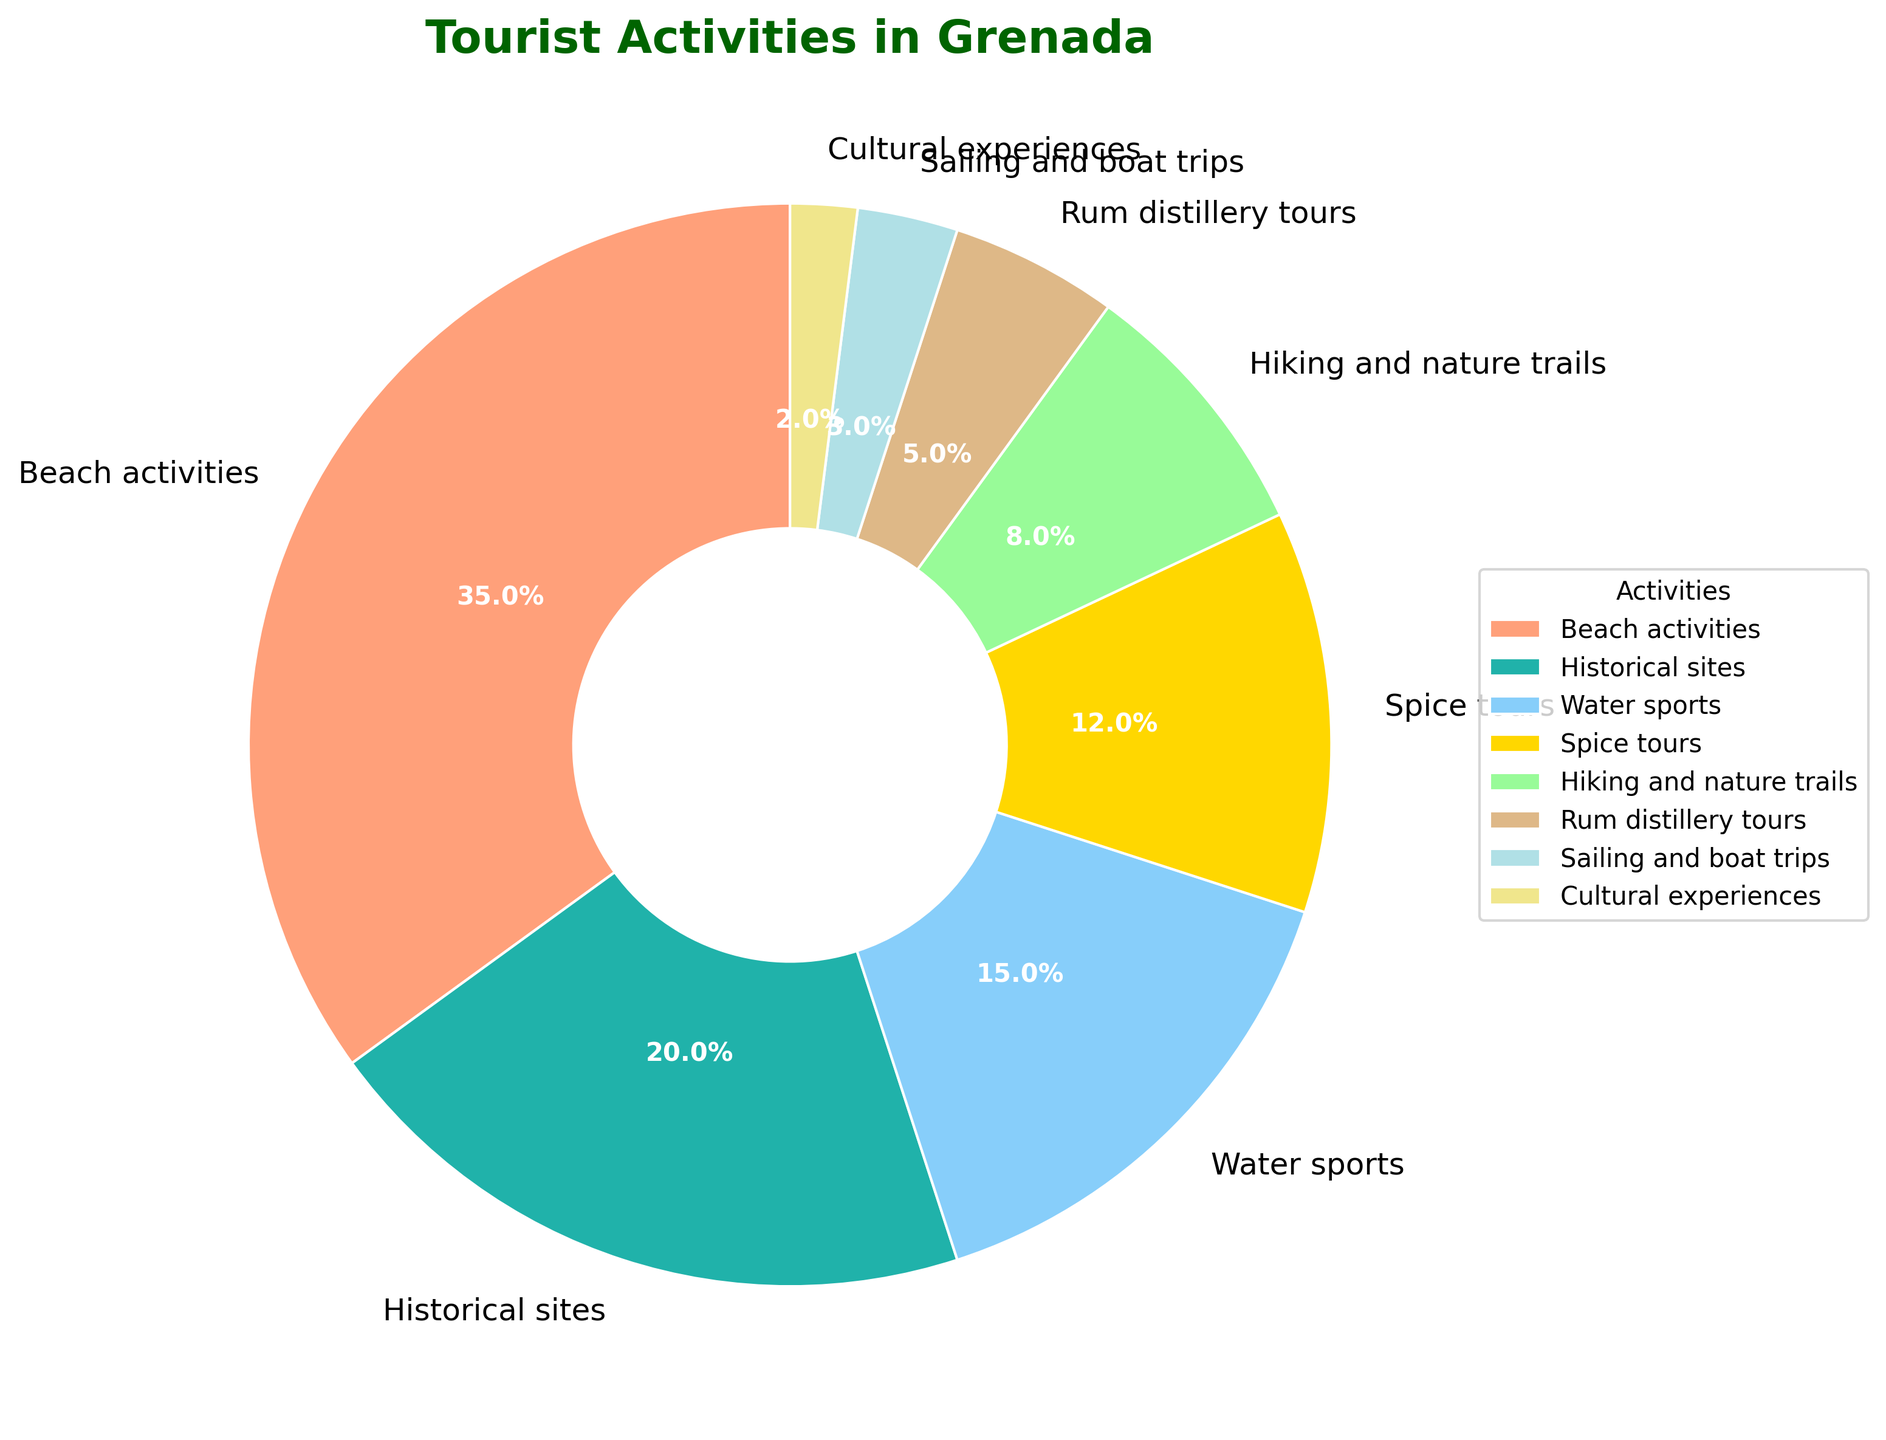What proportion of tourist activities is dedicated to beach activities? The pie chart shows the percentage of each tourist activity. According to the chart, the proportion dedicated to beach activities is labeled directly in the section for Beach activities.
Answer: 35% Which activity has the smallest percentage share? By examining the pie chart, the smallest segment can be identified by its size and the percentage label. The smallest segment is labeled as Cultural experiences with a 2% share.
Answer: Cultural experiences What is the combined percentage for water sports and hiking and nature trails? To find the combined percentage, add the percentages for Water sports and Hiking and nature trails. The chart indicates Water sports have 15% and Hiking and nature trails have 8%. So, 15% + 8% = 23%.
Answer: 23% Which is more popular: spice tours or rum distillery tours? The sizes and percentages of the segments in the chart indicate the popularity. Spice tours are labeled with 12%, while Rum distillery tours are labeled with 5%. Therefore, Spice tours are more popular.
Answer: Spice tours How does the proportion of historical site visits compare to beach activities? By comparing the percentage values in the pie chart, Historical sites have a 20% share, and Beach activities have a 35% share. We see that Beach activities have a larger proportion.
Answer: Beach activities have a larger proportion Which activity categories together make up exactly half of the tourist activities? To find the activities making up 50%, identify segments whose percentages add up to 50%. Beach activities (35%) and Historical sites (20%) together make 55%, but Beach activities (35%) and Water sports (15%) together make 50%.
Answer: Beach activities and Water sports How many percentage points greater is beach activities than sailing and boat trips? To find out, subtract the percentage for Sailing and boat trips from Beach activities. The percentages are 35% for Beach activities and 3% for Sailing and boat trips. The difference is 35% - 3% = 32% points.
Answer: 32% points What percentage of activities are neither related to water (beach, water sports, sailing) nor involve spice tours? First, add the percentages for Beach activities (35%), Water sports (15%), Sailing and boat trips (3%) and Spice tours (12%). This sum is 65%. The percentage of activities not related to these is 100% - 65% = 35%.
Answer: 35% Which activities, together, have less than 10% share? By examining the sizes and percentages of the segments, identify the activities with less than 10%. These are Rum distillery tours (5%), Sailing and boat trips (3%), and Cultural experiences (2%). Together, they sum up to 5% + 3% + 2% = 10% (but the Brewery tours are slightly above 10%).
Answer: Cultural experiences, Sailing and boat trips, and Rum distillery tours 